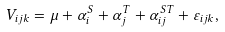<formula> <loc_0><loc_0><loc_500><loc_500>V _ { i j k } = \mu + \alpha _ { i } ^ { S } + \alpha _ { j } ^ { T } + \alpha _ { i j } ^ { S T } + \varepsilon _ { i j k } ,</formula> 